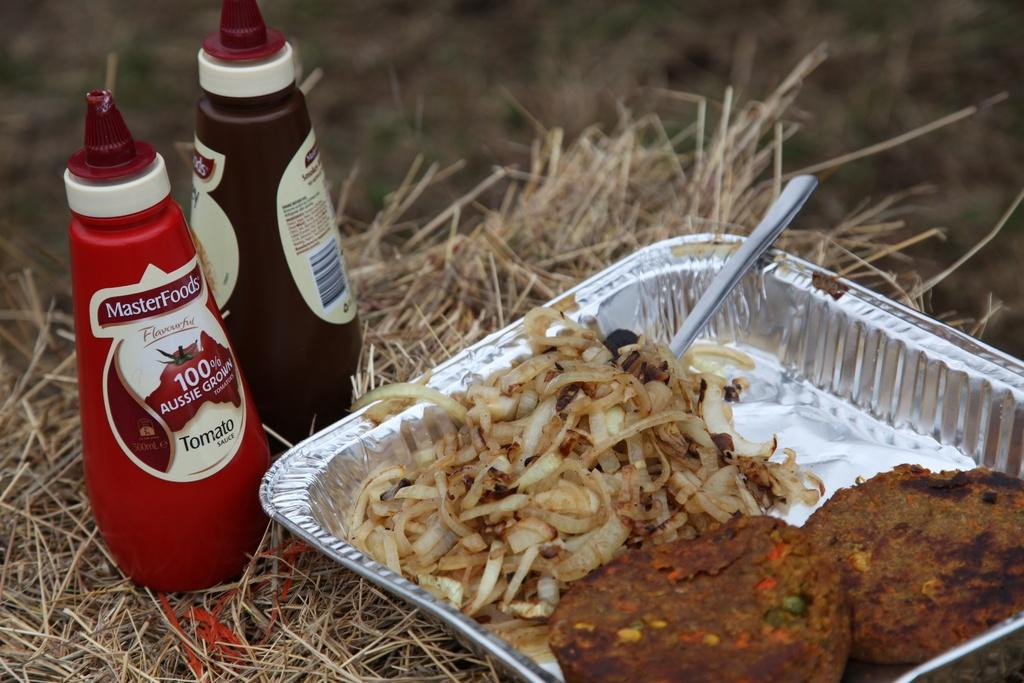<image>
Render a clear and concise summary of the photo. A metal serving pan full of food lies in some grass next to two MasterFoods condiment bottles. 